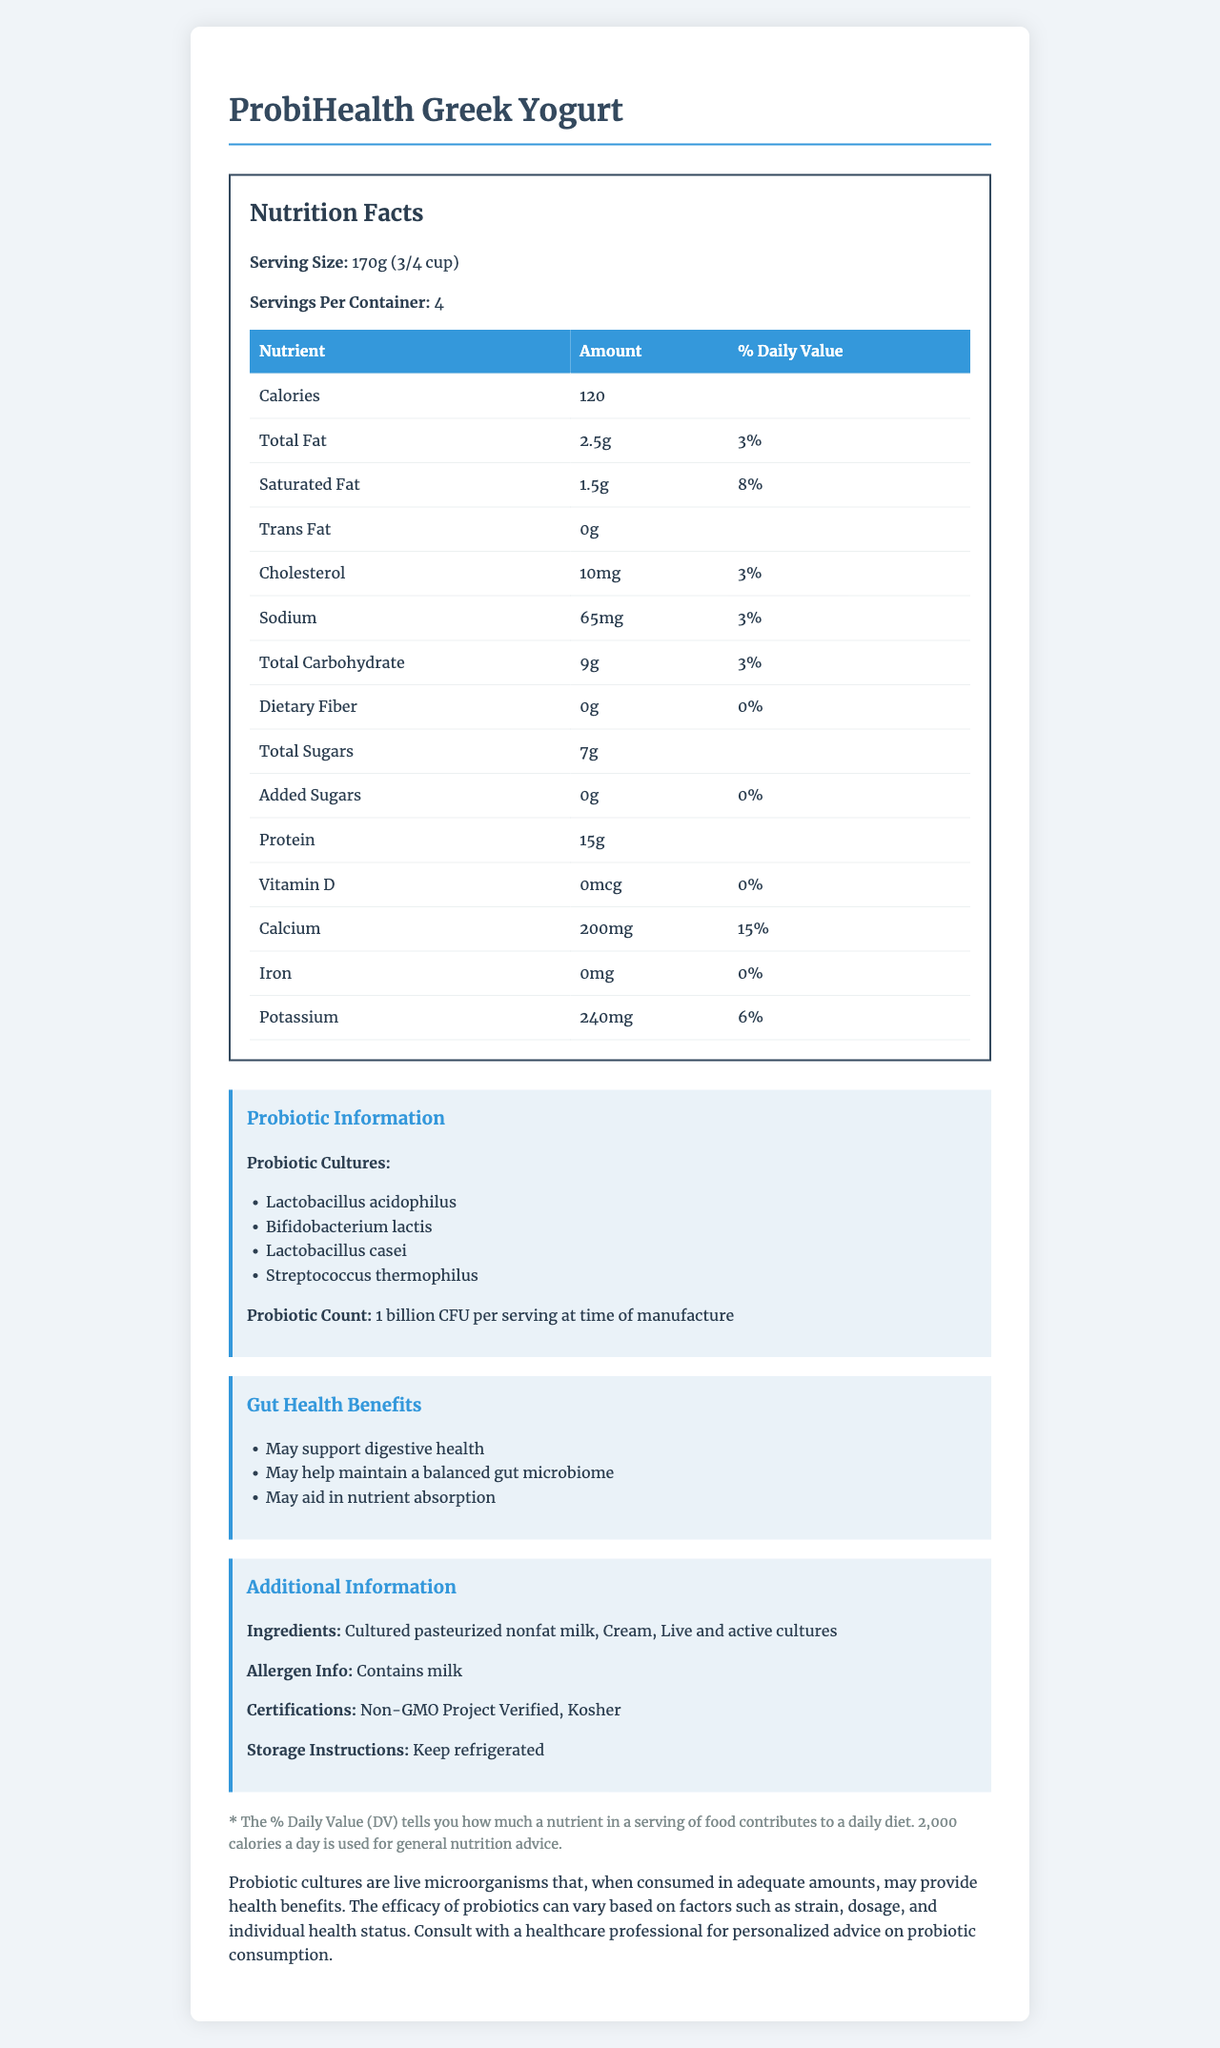what is the serving size of ProbiHealth Greek Yogurt? The serving size is clearly mentioned in the Nutrition Facts section under "Serving Size."
Answer: 170g (3/4 cup) how many servings are there per container? The number of servings per container is provided in the Nutrition Facts section under "Servings Per Container."
Answer: 4 how many calories are in a serving of ProbiHealth Greek Yogurt? The caloric content per serving is mentioned in the Nutrition Facts section under "Calories."
Answer: 120 what probiotics are present in this yogurt? The probiotics are listed in the Probiotic Information section under "Probiotic Cultures."
Answer: Lactobacillus acidophilus, Bifidobacterium lactis, Lactobacillus casei, Streptococcus thermophilus does this yogurt contain any added sugars? The Nutrition Facts section indicates that the amount of added sugars is 0g.
Answer: No what are the main ingredients of this probiotic yogurt? The main ingredients are listed in the Additional Information section under "Ingredients."
Answer: Cultured pasteurized nonfat milk, Cream, Live and active cultures what is the daily value percentage of calcium in a serving? The daily value percentage for calcium is provided in the Nutrition Facts table under "Calcium."
Answer: 15% how much protein is in one serving of this yogurt? The protein content per serving is listed in the Nutrition Facts section under "Protein."
Answer: 15g which of the following is a benefit of this yogurt for gut health? A. May help weight loss B. May support digestive health C. May improve skin health D. May reduce anxiety The benefits for gut health are listed, and "May support digestive health" is one of them.
Answer: B what certifications does this yogurt have? A. Organic B. Non-GMO Project Verified C. Gluten-Free D. Low Sodium The certifications are listed as "Non-GMO Project Verified" and "Kosher."
Answer: B does this yogurt contain milk? The allergen information in the Additional Information section explicitly states that it contains milk.
Answer: Yes summarize the key nutritional and additional information for ProbiHealth Greek Yogurt The summary captures the major points from the Nutrition Facts, Probiotic Information, Gut Health Benefits, and Additional Information sections.
Answer: ProbiHealth Greek Yogurt contains 120 calories per serving, 2.5g total fat, 15g protein, and is rich in beneficial probiotic cultures. It has certifications like Non-GMO Project Verified and Kosher, and includes ingredients such as cultured pasteurized nonfat milk and cream. The yogurt offers gut health benefits, such as supporting digestive health. who is the manufacturer of ProbiHealth Greek Yogurt? The document does not provide any information about the manufacturer of the yogurt.
Answer: Cannot be determined 